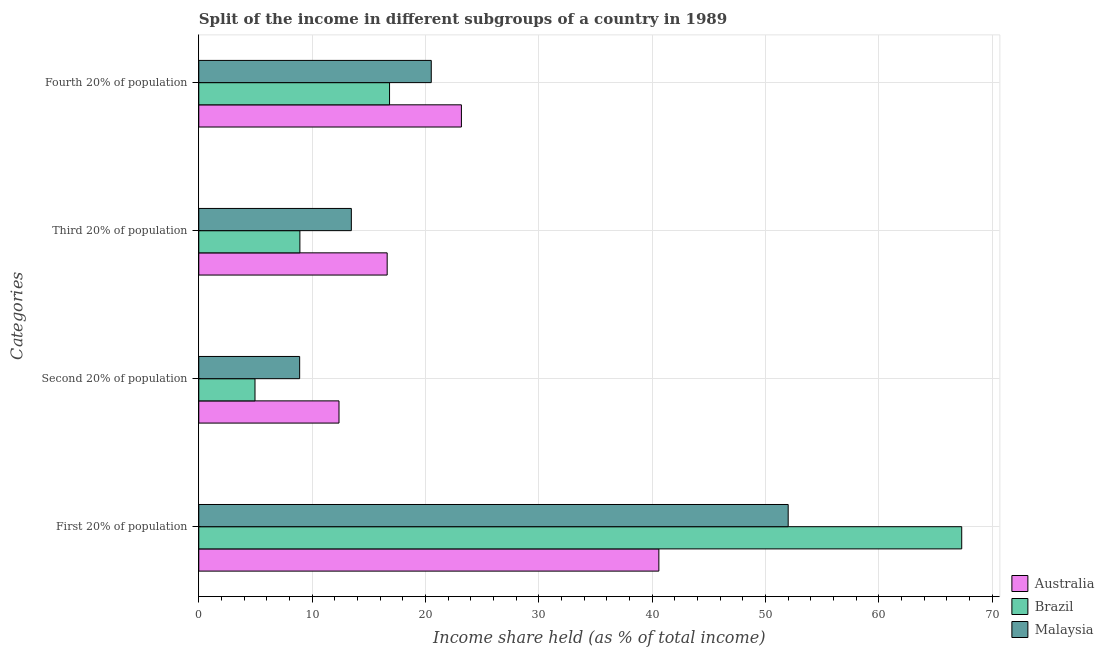How many different coloured bars are there?
Your response must be concise. 3. How many groups of bars are there?
Provide a short and direct response. 4. What is the label of the 1st group of bars from the top?
Keep it short and to the point. Fourth 20% of population. What is the share of the income held by third 20% of the population in Brazil?
Your response must be concise. 8.92. Across all countries, what is the maximum share of the income held by fourth 20% of the population?
Your answer should be compact. 23.17. Across all countries, what is the minimum share of the income held by fourth 20% of the population?
Provide a short and direct response. 16.83. In which country was the share of the income held by third 20% of the population maximum?
Ensure brevity in your answer.  Australia. What is the total share of the income held by fourth 20% of the population in the graph?
Provide a succinct answer. 60.51. What is the difference between the share of the income held by fourth 20% of the population in Australia and that in Brazil?
Your response must be concise. 6.34. What is the difference between the share of the income held by fourth 20% of the population in Australia and the share of the income held by third 20% of the population in Brazil?
Ensure brevity in your answer.  14.25. What is the average share of the income held by first 20% of the population per country?
Keep it short and to the point. 53.3. What is the difference between the share of the income held by third 20% of the population and share of the income held by fourth 20% of the population in Australia?
Your response must be concise. -6.55. In how many countries, is the share of the income held by third 20% of the population greater than 30 %?
Your answer should be very brief. 0. What is the ratio of the share of the income held by second 20% of the population in Malaysia to that in Australia?
Keep it short and to the point. 0.72. Is the difference between the share of the income held by third 20% of the population in Brazil and Malaysia greater than the difference between the share of the income held by fourth 20% of the population in Brazil and Malaysia?
Give a very brief answer. No. What is the difference between the highest and the second highest share of the income held by first 20% of the population?
Your response must be concise. 15.31. What is the difference between the highest and the lowest share of the income held by second 20% of the population?
Provide a short and direct response. 7.41. In how many countries, is the share of the income held by third 20% of the population greater than the average share of the income held by third 20% of the population taken over all countries?
Offer a terse response. 2. Is it the case that in every country, the sum of the share of the income held by fourth 20% of the population and share of the income held by third 20% of the population is greater than the sum of share of the income held by second 20% of the population and share of the income held by first 20% of the population?
Offer a very short reply. No. What does the 2nd bar from the top in Fourth 20% of population represents?
Ensure brevity in your answer.  Brazil. What does the 3rd bar from the bottom in First 20% of population represents?
Offer a terse response. Malaysia. What is the difference between two consecutive major ticks on the X-axis?
Provide a short and direct response. 10. What is the title of the graph?
Offer a terse response. Split of the income in different subgroups of a country in 1989. What is the label or title of the X-axis?
Give a very brief answer. Income share held (as % of total income). What is the label or title of the Y-axis?
Your answer should be compact. Categories. What is the Income share held (as % of total income) of Australia in First 20% of population?
Give a very brief answer. 40.59. What is the Income share held (as % of total income) in Brazil in First 20% of population?
Keep it short and to the point. 67.31. What is the Income share held (as % of total income) in Australia in Second 20% of population?
Offer a terse response. 12.37. What is the Income share held (as % of total income) of Brazil in Second 20% of population?
Your answer should be compact. 4.96. What is the Income share held (as % of total income) of Malaysia in Second 20% of population?
Ensure brevity in your answer.  8.9. What is the Income share held (as % of total income) in Australia in Third 20% of population?
Your answer should be very brief. 16.62. What is the Income share held (as % of total income) of Brazil in Third 20% of population?
Ensure brevity in your answer.  8.92. What is the Income share held (as % of total income) in Malaysia in Third 20% of population?
Provide a succinct answer. 13.46. What is the Income share held (as % of total income) of Australia in Fourth 20% of population?
Keep it short and to the point. 23.17. What is the Income share held (as % of total income) in Brazil in Fourth 20% of population?
Provide a succinct answer. 16.83. What is the Income share held (as % of total income) in Malaysia in Fourth 20% of population?
Ensure brevity in your answer.  20.51. Across all Categories, what is the maximum Income share held (as % of total income) of Australia?
Keep it short and to the point. 40.59. Across all Categories, what is the maximum Income share held (as % of total income) in Brazil?
Your answer should be compact. 67.31. Across all Categories, what is the minimum Income share held (as % of total income) in Australia?
Make the answer very short. 12.37. Across all Categories, what is the minimum Income share held (as % of total income) of Brazil?
Provide a short and direct response. 4.96. What is the total Income share held (as % of total income) of Australia in the graph?
Your response must be concise. 92.75. What is the total Income share held (as % of total income) of Brazil in the graph?
Offer a terse response. 98.02. What is the total Income share held (as % of total income) of Malaysia in the graph?
Your response must be concise. 94.87. What is the difference between the Income share held (as % of total income) in Australia in First 20% of population and that in Second 20% of population?
Give a very brief answer. 28.22. What is the difference between the Income share held (as % of total income) of Brazil in First 20% of population and that in Second 20% of population?
Provide a succinct answer. 62.35. What is the difference between the Income share held (as % of total income) of Malaysia in First 20% of population and that in Second 20% of population?
Offer a very short reply. 43.1. What is the difference between the Income share held (as % of total income) of Australia in First 20% of population and that in Third 20% of population?
Your answer should be compact. 23.97. What is the difference between the Income share held (as % of total income) of Brazil in First 20% of population and that in Third 20% of population?
Give a very brief answer. 58.39. What is the difference between the Income share held (as % of total income) in Malaysia in First 20% of population and that in Third 20% of population?
Ensure brevity in your answer.  38.54. What is the difference between the Income share held (as % of total income) of Australia in First 20% of population and that in Fourth 20% of population?
Keep it short and to the point. 17.42. What is the difference between the Income share held (as % of total income) in Brazil in First 20% of population and that in Fourth 20% of population?
Offer a terse response. 50.48. What is the difference between the Income share held (as % of total income) in Malaysia in First 20% of population and that in Fourth 20% of population?
Your response must be concise. 31.49. What is the difference between the Income share held (as % of total income) of Australia in Second 20% of population and that in Third 20% of population?
Your response must be concise. -4.25. What is the difference between the Income share held (as % of total income) of Brazil in Second 20% of population and that in Third 20% of population?
Ensure brevity in your answer.  -3.96. What is the difference between the Income share held (as % of total income) of Malaysia in Second 20% of population and that in Third 20% of population?
Provide a succinct answer. -4.56. What is the difference between the Income share held (as % of total income) of Brazil in Second 20% of population and that in Fourth 20% of population?
Keep it short and to the point. -11.87. What is the difference between the Income share held (as % of total income) of Malaysia in Second 20% of population and that in Fourth 20% of population?
Your answer should be very brief. -11.61. What is the difference between the Income share held (as % of total income) in Australia in Third 20% of population and that in Fourth 20% of population?
Make the answer very short. -6.55. What is the difference between the Income share held (as % of total income) in Brazil in Third 20% of population and that in Fourth 20% of population?
Offer a very short reply. -7.91. What is the difference between the Income share held (as % of total income) of Malaysia in Third 20% of population and that in Fourth 20% of population?
Your response must be concise. -7.05. What is the difference between the Income share held (as % of total income) in Australia in First 20% of population and the Income share held (as % of total income) in Brazil in Second 20% of population?
Make the answer very short. 35.63. What is the difference between the Income share held (as % of total income) in Australia in First 20% of population and the Income share held (as % of total income) in Malaysia in Second 20% of population?
Give a very brief answer. 31.69. What is the difference between the Income share held (as % of total income) of Brazil in First 20% of population and the Income share held (as % of total income) of Malaysia in Second 20% of population?
Ensure brevity in your answer.  58.41. What is the difference between the Income share held (as % of total income) of Australia in First 20% of population and the Income share held (as % of total income) of Brazil in Third 20% of population?
Your response must be concise. 31.67. What is the difference between the Income share held (as % of total income) of Australia in First 20% of population and the Income share held (as % of total income) of Malaysia in Third 20% of population?
Your response must be concise. 27.13. What is the difference between the Income share held (as % of total income) of Brazil in First 20% of population and the Income share held (as % of total income) of Malaysia in Third 20% of population?
Ensure brevity in your answer.  53.85. What is the difference between the Income share held (as % of total income) of Australia in First 20% of population and the Income share held (as % of total income) of Brazil in Fourth 20% of population?
Ensure brevity in your answer.  23.76. What is the difference between the Income share held (as % of total income) of Australia in First 20% of population and the Income share held (as % of total income) of Malaysia in Fourth 20% of population?
Your response must be concise. 20.08. What is the difference between the Income share held (as % of total income) in Brazil in First 20% of population and the Income share held (as % of total income) in Malaysia in Fourth 20% of population?
Give a very brief answer. 46.8. What is the difference between the Income share held (as % of total income) of Australia in Second 20% of population and the Income share held (as % of total income) of Brazil in Third 20% of population?
Keep it short and to the point. 3.45. What is the difference between the Income share held (as % of total income) in Australia in Second 20% of population and the Income share held (as % of total income) in Malaysia in Third 20% of population?
Provide a short and direct response. -1.09. What is the difference between the Income share held (as % of total income) in Australia in Second 20% of population and the Income share held (as % of total income) in Brazil in Fourth 20% of population?
Make the answer very short. -4.46. What is the difference between the Income share held (as % of total income) in Australia in Second 20% of population and the Income share held (as % of total income) in Malaysia in Fourth 20% of population?
Your response must be concise. -8.14. What is the difference between the Income share held (as % of total income) of Brazil in Second 20% of population and the Income share held (as % of total income) of Malaysia in Fourth 20% of population?
Make the answer very short. -15.55. What is the difference between the Income share held (as % of total income) in Australia in Third 20% of population and the Income share held (as % of total income) in Brazil in Fourth 20% of population?
Your response must be concise. -0.21. What is the difference between the Income share held (as % of total income) of Australia in Third 20% of population and the Income share held (as % of total income) of Malaysia in Fourth 20% of population?
Make the answer very short. -3.89. What is the difference between the Income share held (as % of total income) of Brazil in Third 20% of population and the Income share held (as % of total income) of Malaysia in Fourth 20% of population?
Make the answer very short. -11.59. What is the average Income share held (as % of total income) in Australia per Categories?
Give a very brief answer. 23.19. What is the average Income share held (as % of total income) in Brazil per Categories?
Offer a terse response. 24.5. What is the average Income share held (as % of total income) of Malaysia per Categories?
Your response must be concise. 23.72. What is the difference between the Income share held (as % of total income) in Australia and Income share held (as % of total income) in Brazil in First 20% of population?
Your answer should be compact. -26.72. What is the difference between the Income share held (as % of total income) in Australia and Income share held (as % of total income) in Malaysia in First 20% of population?
Your response must be concise. -11.41. What is the difference between the Income share held (as % of total income) in Brazil and Income share held (as % of total income) in Malaysia in First 20% of population?
Make the answer very short. 15.31. What is the difference between the Income share held (as % of total income) of Australia and Income share held (as % of total income) of Brazil in Second 20% of population?
Your response must be concise. 7.41. What is the difference between the Income share held (as % of total income) of Australia and Income share held (as % of total income) of Malaysia in Second 20% of population?
Your answer should be very brief. 3.47. What is the difference between the Income share held (as % of total income) in Brazil and Income share held (as % of total income) in Malaysia in Second 20% of population?
Provide a short and direct response. -3.94. What is the difference between the Income share held (as % of total income) of Australia and Income share held (as % of total income) of Brazil in Third 20% of population?
Keep it short and to the point. 7.7. What is the difference between the Income share held (as % of total income) of Australia and Income share held (as % of total income) of Malaysia in Third 20% of population?
Your answer should be compact. 3.16. What is the difference between the Income share held (as % of total income) in Brazil and Income share held (as % of total income) in Malaysia in Third 20% of population?
Your answer should be very brief. -4.54. What is the difference between the Income share held (as % of total income) of Australia and Income share held (as % of total income) of Brazil in Fourth 20% of population?
Provide a short and direct response. 6.34. What is the difference between the Income share held (as % of total income) of Australia and Income share held (as % of total income) of Malaysia in Fourth 20% of population?
Your response must be concise. 2.66. What is the difference between the Income share held (as % of total income) of Brazil and Income share held (as % of total income) of Malaysia in Fourth 20% of population?
Make the answer very short. -3.68. What is the ratio of the Income share held (as % of total income) of Australia in First 20% of population to that in Second 20% of population?
Ensure brevity in your answer.  3.28. What is the ratio of the Income share held (as % of total income) in Brazil in First 20% of population to that in Second 20% of population?
Make the answer very short. 13.57. What is the ratio of the Income share held (as % of total income) in Malaysia in First 20% of population to that in Second 20% of population?
Provide a short and direct response. 5.84. What is the ratio of the Income share held (as % of total income) in Australia in First 20% of population to that in Third 20% of population?
Offer a terse response. 2.44. What is the ratio of the Income share held (as % of total income) of Brazil in First 20% of population to that in Third 20% of population?
Your answer should be compact. 7.55. What is the ratio of the Income share held (as % of total income) in Malaysia in First 20% of population to that in Third 20% of population?
Your answer should be very brief. 3.86. What is the ratio of the Income share held (as % of total income) of Australia in First 20% of population to that in Fourth 20% of population?
Make the answer very short. 1.75. What is the ratio of the Income share held (as % of total income) in Brazil in First 20% of population to that in Fourth 20% of population?
Keep it short and to the point. 4. What is the ratio of the Income share held (as % of total income) in Malaysia in First 20% of population to that in Fourth 20% of population?
Offer a terse response. 2.54. What is the ratio of the Income share held (as % of total income) in Australia in Second 20% of population to that in Third 20% of population?
Ensure brevity in your answer.  0.74. What is the ratio of the Income share held (as % of total income) in Brazil in Second 20% of population to that in Third 20% of population?
Your answer should be compact. 0.56. What is the ratio of the Income share held (as % of total income) of Malaysia in Second 20% of population to that in Third 20% of population?
Your answer should be very brief. 0.66. What is the ratio of the Income share held (as % of total income) in Australia in Second 20% of population to that in Fourth 20% of population?
Give a very brief answer. 0.53. What is the ratio of the Income share held (as % of total income) of Brazil in Second 20% of population to that in Fourth 20% of population?
Offer a very short reply. 0.29. What is the ratio of the Income share held (as % of total income) in Malaysia in Second 20% of population to that in Fourth 20% of population?
Provide a short and direct response. 0.43. What is the ratio of the Income share held (as % of total income) of Australia in Third 20% of population to that in Fourth 20% of population?
Ensure brevity in your answer.  0.72. What is the ratio of the Income share held (as % of total income) in Brazil in Third 20% of population to that in Fourth 20% of population?
Offer a terse response. 0.53. What is the ratio of the Income share held (as % of total income) in Malaysia in Third 20% of population to that in Fourth 20% of population?
Keep it short and to the point. 0.66. What is the difference between the highest and the second highest Income share held (as % of total income) of Australia?
Provide a short and direct response. 17.42. What is the difference between the highest and the second highest Income share held (as % of total income) of Brazil?
Give a very brief answer. 50.48. What is the difference between the highest and the second highest Income share held (as % of total income) of Malaysia?
Provide a short and direct response. 31.49. What is the difference between the highest and the lowest Income share held (as % of total income) of Australia?
Make the answer very short. 28.22. What is the difference between the highest and the lowest Income share held (as % of total income) in Brazil?
Provide a succinct answer. 62.35. What is the difference between the highest and the lowest Income share held (as % of total income) of Malaysia?
Offer a very short reply. 43.1. 